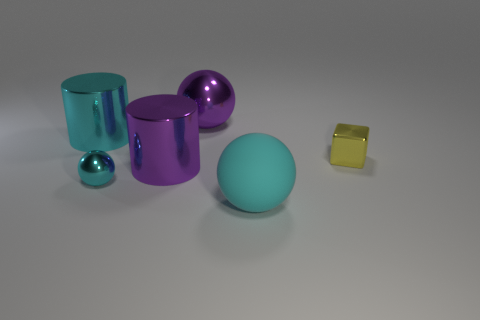What can you infer about the lighting source in this image, based on the reflections and shadows? The lighting in this image appears to be ambient and diffuse, with soft shadows cast by the objects indicating an overhead light source. The reflections on the shiny surfaces suggest the light may be bright yet not very harsh, creating a gentle glow on the objects and imbuing the scene with a serene, almost ethereal quality. 